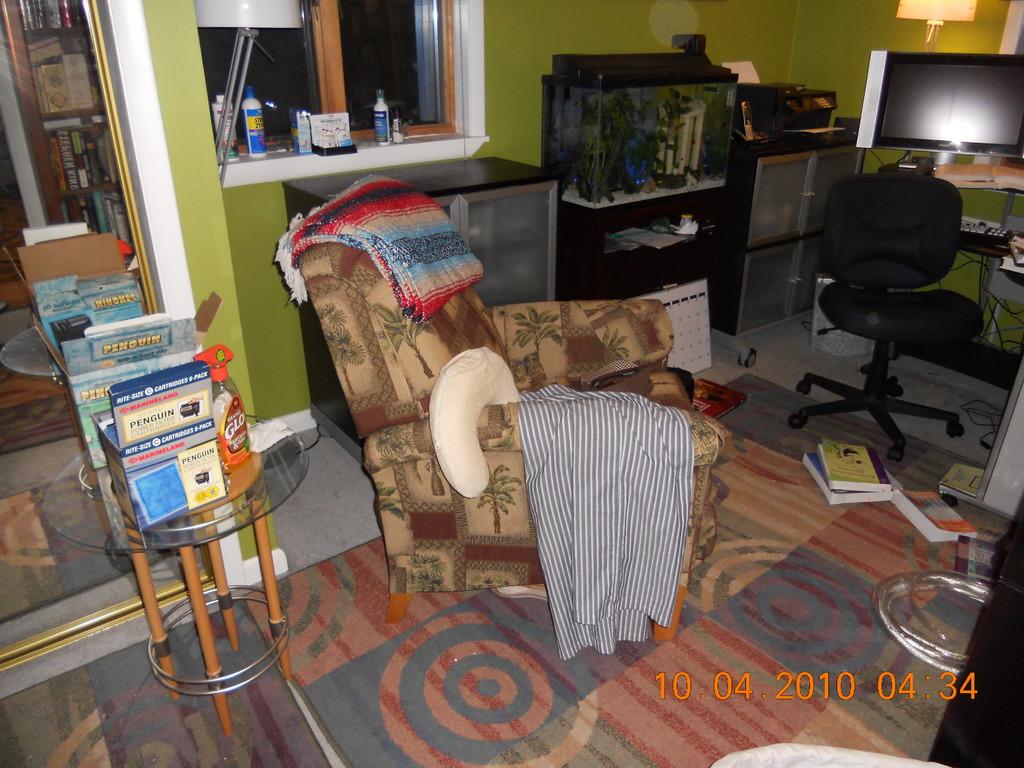What month is it in this photo?
Give a very brief answer. October. 